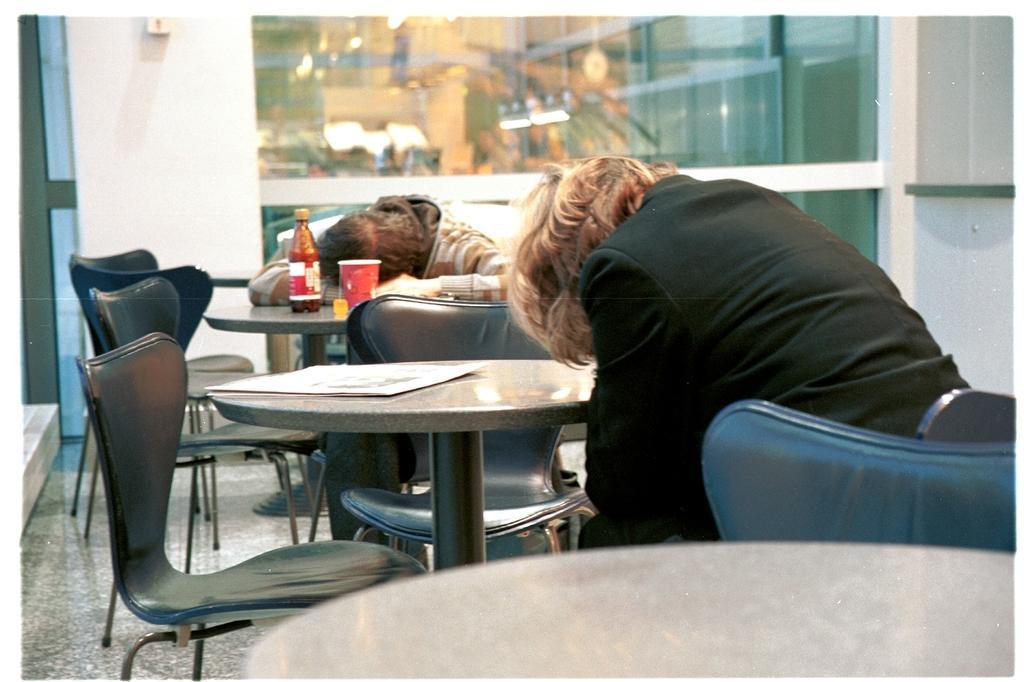Can you describe this image briefly? In this image we can see some persons sitting on chairs around the tables, there are some bottles, glasses on the table and in the foreground of the image there is newspaper on the table and in the background of the image there is a wall and glass sheet. 